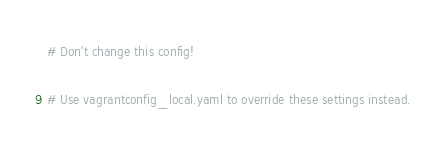<code> <loc_0><loc_0><loc_500><loc_500><_YAML_># Don't change this config!

# Use vagrantconfig_local.yaml to override these settings instead.

</code> 